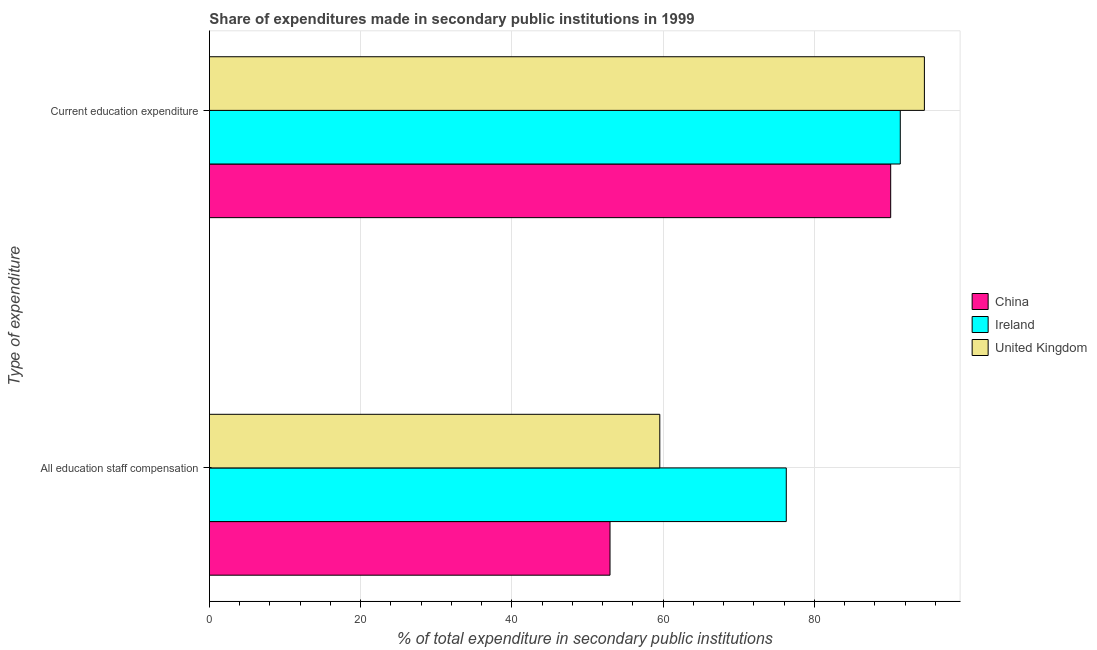How many groups of bars are there?
Your response must be concise. 2. Are the number of bars on each tick of the Y-axis equal?
Your answer should be very brief. Yes. How many bars are there on the 2nd tick from the top?
Your answer should be compact. 3. What is the label of the 2nd group of bars from the top?
Offer a terse response. All education staff compensation. What is the expenditure in staff compensation in Ireland?
Your answer should be very brief. 76.3. Across all countries, what is the maximum expenditure in staff compensation?
Give a very brief answer. 76.3. Across all countries, what is the minimum expenditure in education?
Provide a succinct answer. 90.11. In which country was the expenditure in staff compensation maximum?
Ensure brevity in your answer.  Ireland. In which country was the expenditure in staff compensation minimum?
Your response must be concise. China. What is the total expenditure in staff compensation in the graph?
Give a very brief answer. 188.85. What is the difference between the expenditure in education in United Kingdom and that in Ireland?
Give a very brief answer. 3.19. What is the difference between the expenditure in education in China and the expenditure in staff compensation in United Kingdom?
Provide a short and direct response. 30.54. What is the average expenditure in education per country?
Give a very brief answer. 92.01. What is the difference between the expenditure in education and expenditure in staff compensation in United Kingdom?
Your answer should be compact. 34.99. What is the ratio of the expenditure in staff compensation in United Kingdom to that in Ireland?
Make the answer very short. 0.78. In how many countries, is the expenditure in staff compensation greater than the average expenditure in staff compensation taken over all countries?
Provide a short and direct response. 1. What does the 1st bar from the top in Current education expenditure represents?
Your response must be concise. United Kingdom. What does the 1st bar from the bottom in Current education expenditure represents?
Your answer should be compact. China. How many countries are there in the graph?
Your answer should be compact. 3. What is the difference between two consecutive major ticks on the X-axis?
Ensure brevity in your answer.  20. Are the values on the major ticks of X-axis written in scientific E-notation?
Your answer should be compact. No. Does the graph contain any zero values?
Your answer should be compact. No. Does the graph contain grids?
Ensure brevity in your answer.  Yes. How many legend labels are there?
Provide a succinct answer. 3. How are the legend labels stacked?
Give a very brief answer. Vertical. What is the title of the graph?
Keep it short and to the point. Share of expenditures made in secondary public institutions in 1999. What is the label or title of the X-axis?
Offer a terse response. % of total expenditure in secondary public institutions. What is the label or title of the Y-axis?
Make the answer very short. Type of expenditure. What is the % of total expenditure in secondary public institutions of China in All education staff compensation?
Offer a terse response. 52.98. What is the % of total expenditure in secondary public institutions of Ireland in All education staff compensation?
Offer a very short reply. 76.3. What is the % of total expenditure in secondary public institutions in United Kingdom in All education staff compensation?
Offer a very short reply. 59.57. What is the % of total expenditure in secondary public institutions in China in Current education expenditure?
Your answer should be very brief. 90.11. What is the % of total expenditure in secondary public institutions in Ireland in Current education expenditure?
Keep it short and to the point. 91.37. What is the % of total expenditure in secondary public institutions of United Kingdom in Current education expenditure?
Your answer should be compact. 94.56. Across all Type of expenditure, what is the maximum % of total expenditure in secondary public institutions in China?
Your response must be concise. 90.11. Across all Type of expenditure, what is the maximum % of total expenditure in secondary public institutions in Ireland?
Your answer should be compact. 91.37. Across all Type of expenditure, what is the maximum % of total expenditure in secondary public institutions of United Kingdom?
Your answer should be very brief. 94.56. Across all Type of expenditure, what is the minimum % of total expenditure in secondary public institutions in China?
Ensure brevity in your answer.  52.98. Across all Type of expenditure, what is the minimum % of total expenditure in secondary public institutions of Ireland?
Provide a short and direct response. 76.3. Across all Type of expenditure, what is the minimum % of total expenditure in secondary public institutions in United Kingdom?
Offer a very short reply. 59.57. What is the total % of total expenditure in secondary public institutions in China in the graph?
Keep it short and to the point. 143.09. What is the total % of total expenditure in secondary public institutions of Ireland in the graph?
Provide a succinct answer. 167.67. What is the total % of total expenditure in secondary public institutions in United Kingdom in the graph?
Your answer should be very brief. 154.13. What is the difference between the % of total expenditure in secondary public institutions of China in All education staff compensation and that in Current education expenditure?
Provide a short and direct response. -37.12. What is the difference between the % of total expenditure in secondary public institutions of Ireland in All education staff compensation and that in Current education expenditure?
Provide a succinct answer. -15.08. What is the difference between the % of total expenditure in secondary public institutions in United Kingdom in All education staff compensation and that in Current education expenditure?
Keep it short and to the point. -34.99. What is the difference between the % of total expenditure in secondary public institutions in China in All education staff compensation and the % of total expenditure in secondary public institutions in Ireland in Current education expenditure?
Your response must be concise. -38.39. What is the difference between the % of total expenditure in secondary public institutions of China in All education staff compensation and the % of total expenditure in secondary public institutions of United Kingdom in Current education expenditure?
Provide a succinct answer. -41.58. What is the difference between the % of total expenditure in secondary public institutions in Ireland in All education staff compensation and the % of total expenditure in secondary public institutions in United Kingdom in Current education expenditure?
Offer a very short reply. -18.27. What is the average % of total expenditure in secondary public institutions of China per Type of expenditure?
Offer a very short reply. 71.54. What is the average % of total expenditure in secondary public institutions in Ireland per Type of expenditure?
Offer a very short reply. 83.84. What is the average % of total expenditure in secondary public institutions in United Kingdom per Type of expenditure?
Make the answer very short. 77.06. What is the difference between the % of total expenditure in secondary public institutions in China and % of total expenditure in secondary public institutions in Ireland in All education staff compensation?
Your answer should be compact. -23.31. What is the difference between the % of total expenditure in secondary public institutions in China and % of total expenditure in secondary public institutions in United Kingdom in All education staff compensation?
Your answer should be very brief. -6.58. What is the difference between the % of total expenditure in secondary public institutions in Ireland and % of total expenditure in secondary public institutions in United Kingdom in All education staff compensation?
Your answer should be compact. 16.73. What is the difference between the % of total expenditure in secondary public institutions of China and % of total expenditure in secondary public institutions of Ireland in Current education expenditure?
Your response must be concise. -1.27. What is the difference between the % of total expenditure in secondary public institutions in China and % of total expenditure in secondary public institutions in United Kingdom in Current education expenditure?
Give a very brief answer. -4.46. What is the difference between the % of total expenditure in secondary public institutions in Ireland and % of total expenditure in secondary public institutions in United Kingdom in Current education expenditure?
Keep it short and to the point. -3.19. What is the ratio of the % of total expenditure in secondary public institutions in China in All education staff compensation to that in Current education expenditure?
Give a very brief answer. 0.59. What is the ratio of the % of total expenditure in secondary public institutions in Ireland in All education staff compensation to that in Current education expenditure?
Keep it short and to the point. 0.83. What is the ratio of the % of total expenditure in secondary public institutions in United Kingdom in All education staff compensation to that in Current education expenditure?
Keep it short and to the point. 0.63. What is the difference between the highest and the second highest % of total expenditure in secondary public institutions in China?
Offer a terse response. 37.12. What is the difference between the highest and the second highest % of total expenditure in secondary public institutions of Ireland?
Give a very brief answer. 15.08. What is the difference between the highest and the second highest % of total expenditure in secondary public institutions in United Kingdom?
Give a very brief answer. 34.99. What is the difference between the highest and the lowest % of total expenditure in secondary public institutions in China?
Keep it short and to the point. 37.12. What is the difference between the highest and the lowest % of total expenditure in secondary public institutions of Ireland?
Keep it short and to the point. 15.08. What is the difference between the highest and the lowest % of total expenditure in secondary public institutions of United Kingdom?
Provide a short and direct response. 34.99. 